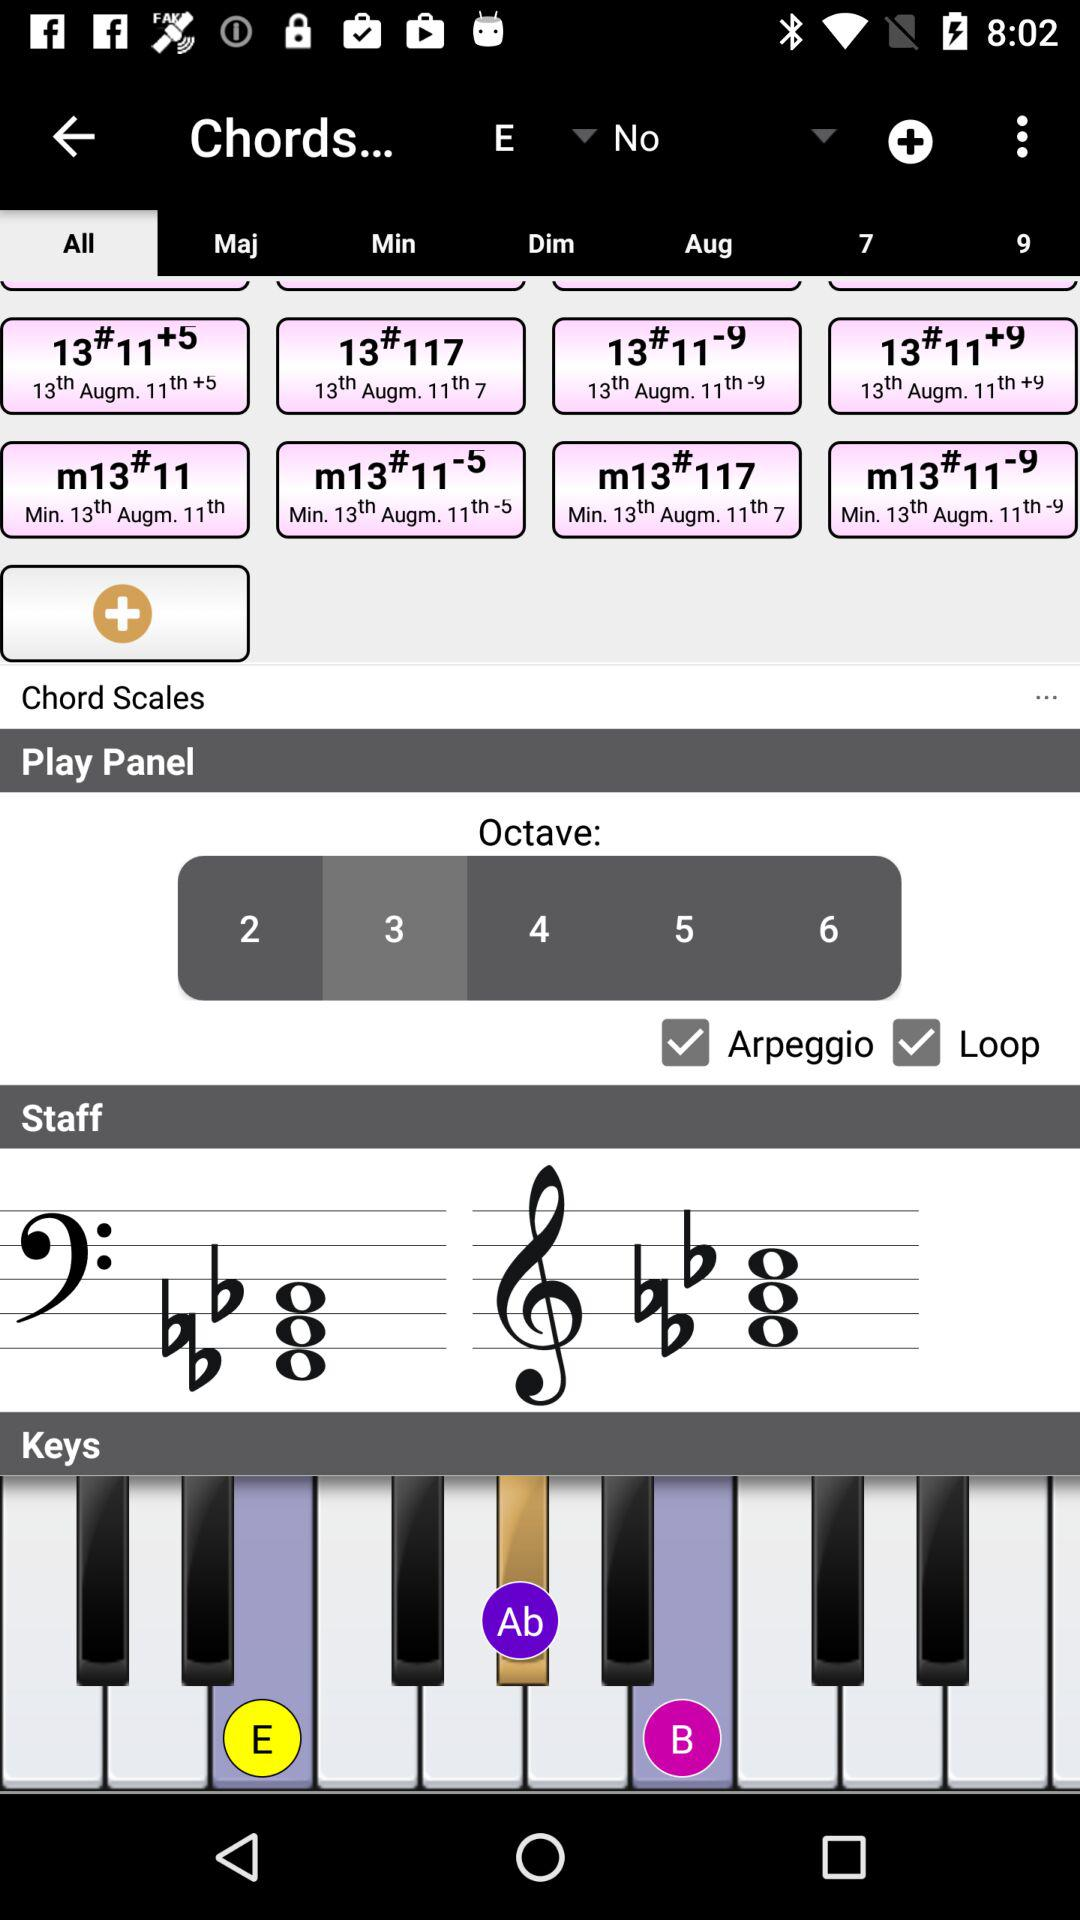What is the selected octave number? The selected octave number is 3. 